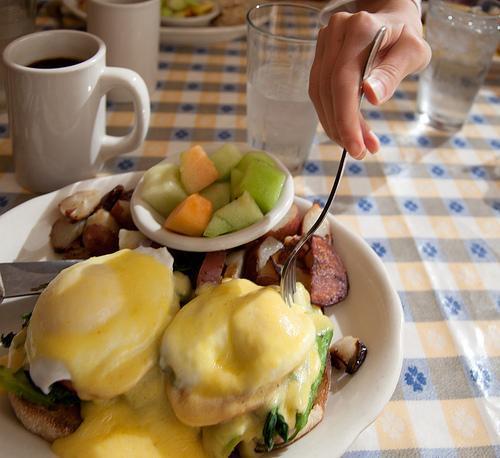How many drinks are in the picture?
Give a very brief answer. 4. 